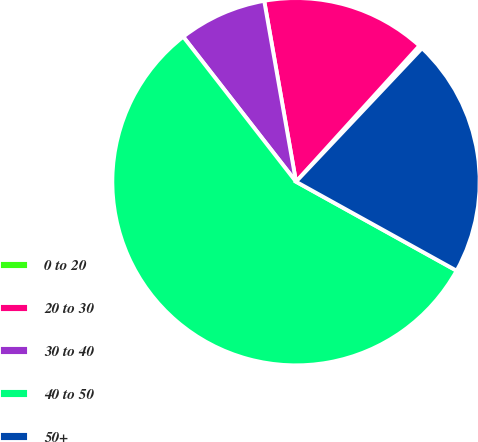<chart> <loc_0><loc_0><loc_500><loc_500><pie_chart><fcel>0 to 20<fcel>20 to 30<fcel>30 to 40<fcel>40 to 50<fcel>50+<nl><fcel>0.31%<fcel>14.5%<fcel>7.75%<fcel>56.42%<fcel>21.01%<nl></chart> 